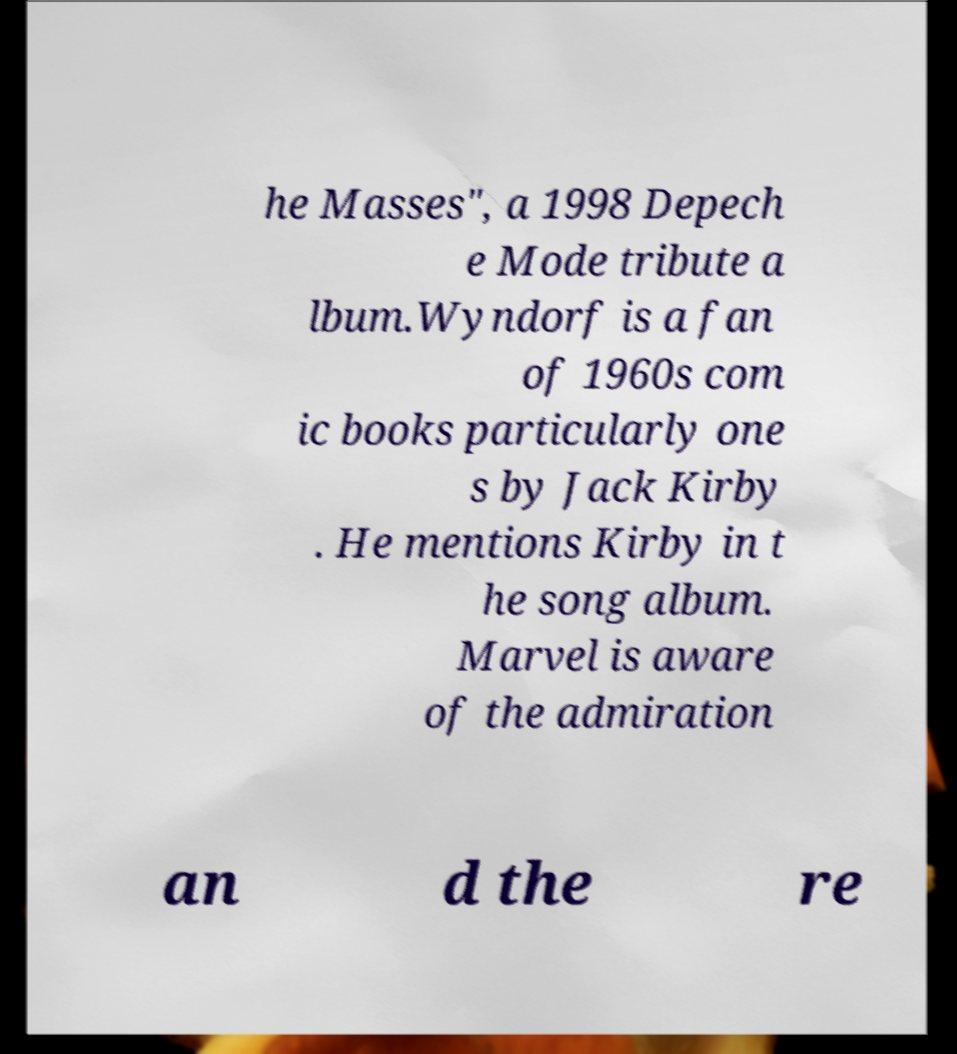Please read and relay the text visible in this image. What does it say? he Masses", a 1998 Depech e Mode tribute a lbum.Wyndorf is a fan of 1960s com ic books particularly one s by Jack Kirby . He mentions Kirby in t he song album. Marvel is aware of the admiration an d the re 